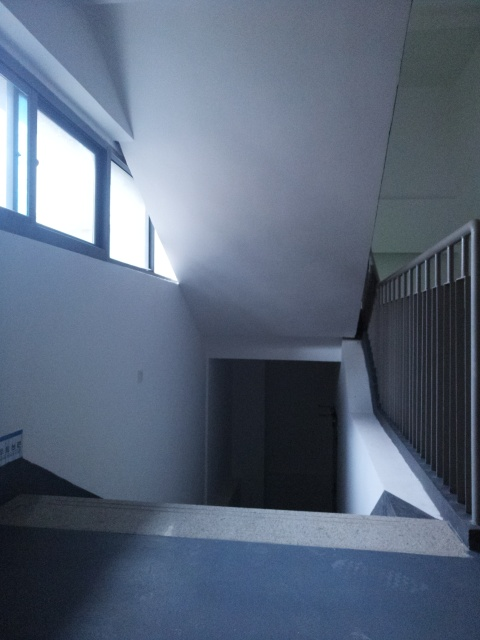What could be the function of this space? This space appears to be a staircase landing in a residential or office building, serving as a transitional area that connects different floors. Its function is primarily utilitarian, facilitating the movement of individuals between levels. Is there anything unusual or noteworthy about this particular staircase landing? While the staircase landing is quite minimalist, the angled ceiling and the placement of the windows add an architectural interest to the space. The asymmetry created by these elements gives the area a modern and dynamic feel. 